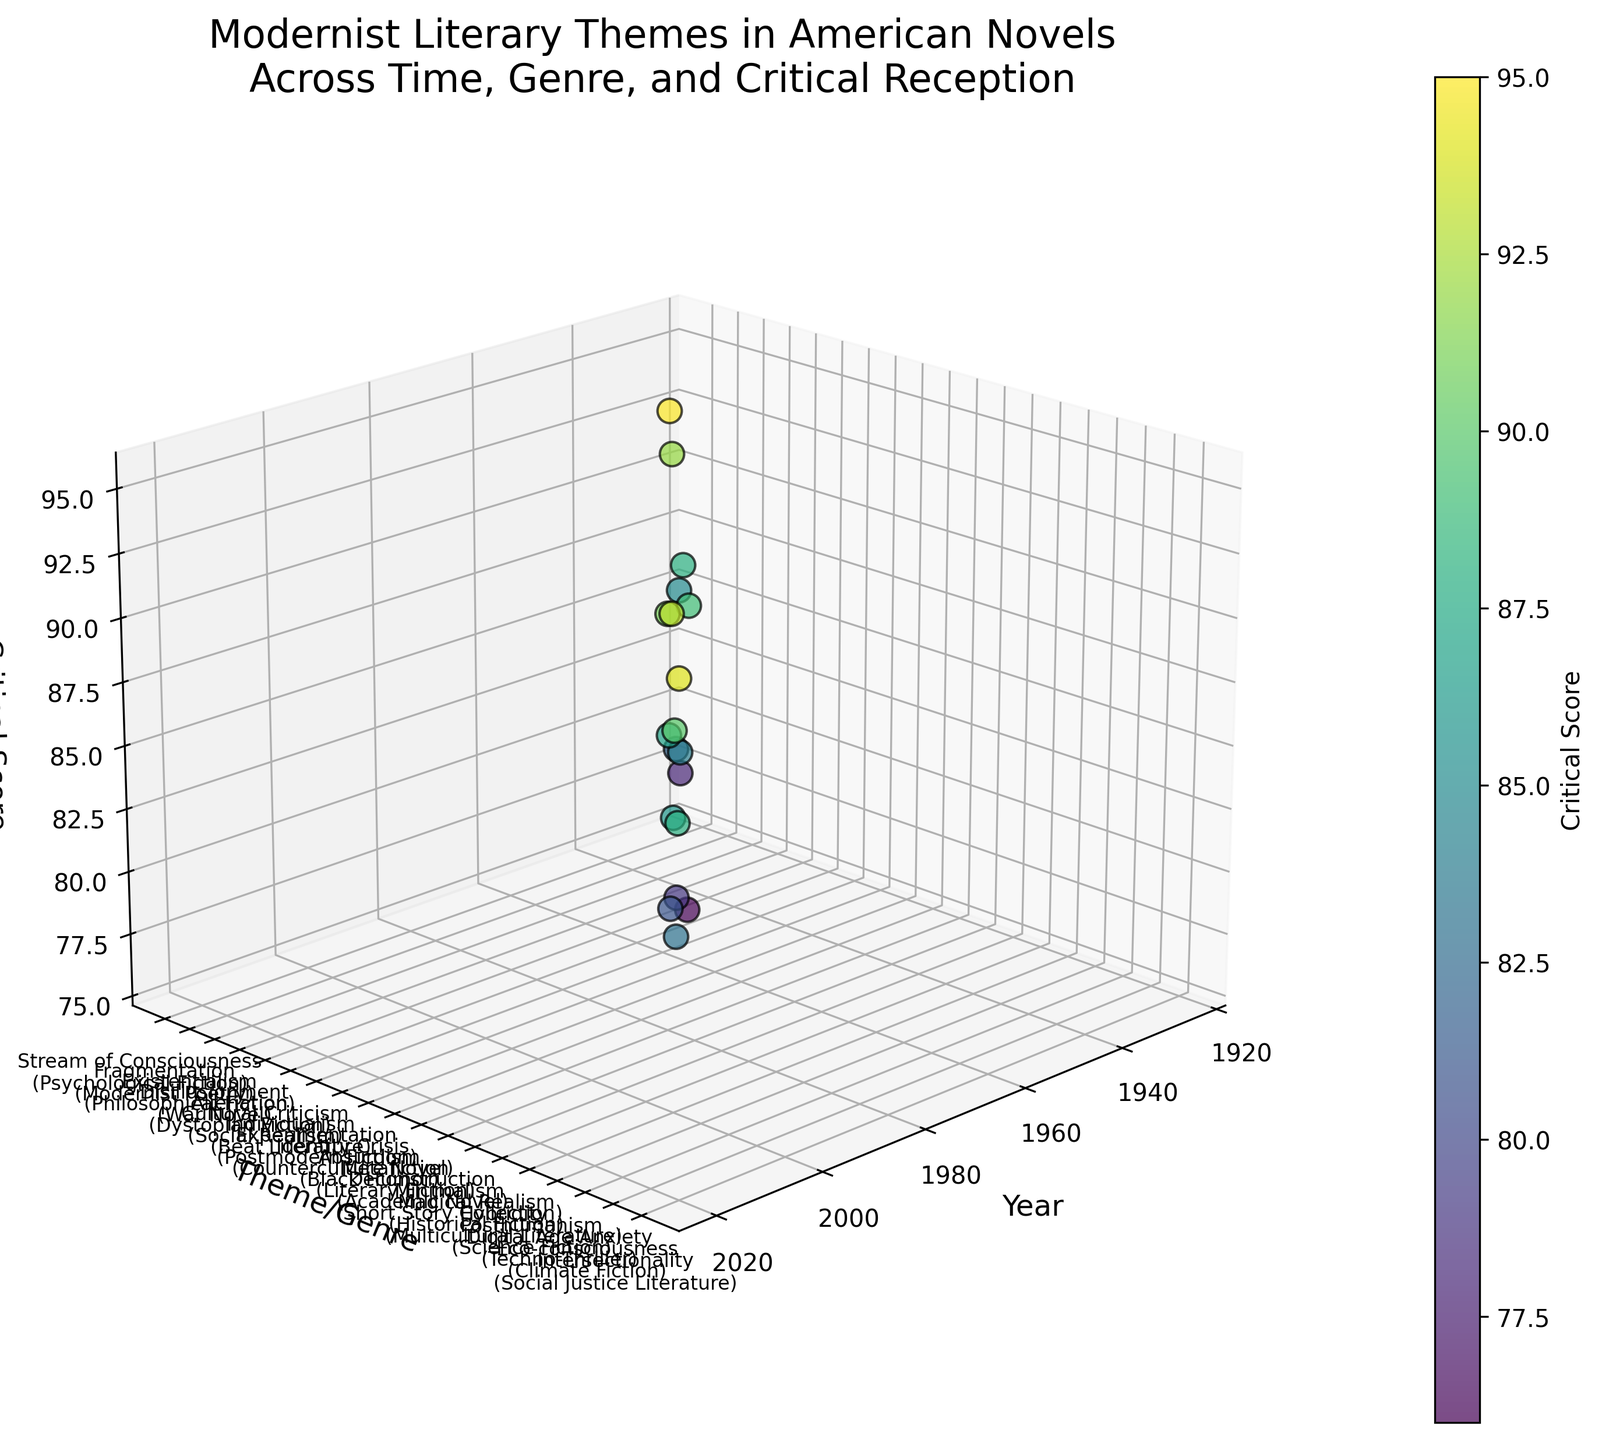What's the title of the figure? The title of the figure is written at the top, it is "Modernist Literary Themes in American Novels Across Time, Genre, and Critical Reception".
Answer: Modernist Literary Themes in American Novels Across Time, Genre, and Critical Reception What is the range of years represented in the plot? To find the range of years, look at the x-axis labeled 'Year'. The earliest year is 1925 and the latest year is 2020.
Answer: 1925 to 2020 Which theme has the highest critical score? Check the highest point along the z-axis labeled 'Critical Score'. The corresponding theme on the y-axis is "Alienation (Dystopian Fiction)" with a score of 95.
Answer: Alienation (Dystopian Fiction) How many data points are shown in the plot? Count the number of points represented in the scatter plot. Each point corresponds to a literary theme from a specific year and genre. There are 19 data points.
Answer: 19 What is the critical score for the theme "Existentialism"? Look for the theme "Existentialism (Philosophical Fiction)" on the y-axis and read the corresponding z-value on the plot. The critical score is 92.
Answer: 92 Which theme/genre combination appears most recent in the plot? Find the point farthest to the right (highest year value) on the x-axis. The theme/genre is "Intersectionality (Social Justice Literature)" in 2020.
Answer: Intersectionality (Social Justice Literature) Which two themes have critical scores that differ by the greatest amount? Identify the themes with the highest and lowest critical scores by observing the z-axis values. "Alienation (Dystopian Fiction)" has the highest score of 95 and "Individualism (Beat Literature)" has the lowest score of 76. The difference is 95 - 76 = 19.
Answer: Alienation (Dystopian Fiction) and Individualism (Beat Literature) What's the average critical score of themes introduced in the 1930s? Find the points with years in the 1930s and calculate the average score. The themes are from the years 1930 (78) and 1937 (92). Their average score is (78 + 92) / 2 = 85.
Answer: 85 Which genre experienced a critical reception above 90 more than once? Observe the points with critical scores above 90 on the z-axis. The genres are "Philosophical Fiction" (92), "Historical Fiction" (93), and "Literary Fiction" (91). "Philosophical Fiction" and "Historical Fiction" appeared only once above 90, "Literary Fiction" appeared once above 90. Therefore, there is no genre that appeared more than once above 90.
Answer: None How does the critical reception score trend over time for themes related to social issues? Identify themes related to social issues and note their scores over the years. Themes include: 1948 ("Alienation" - 95), 1952 ("Cultural Criticism" - 82), 2015 ("Eco-consciousness" - 88), 2020 ("Intersectionality" - 94). The scores generally remain high, with some fluctuation reflecting diverse critical receptions.
Answer: Scores generally high 